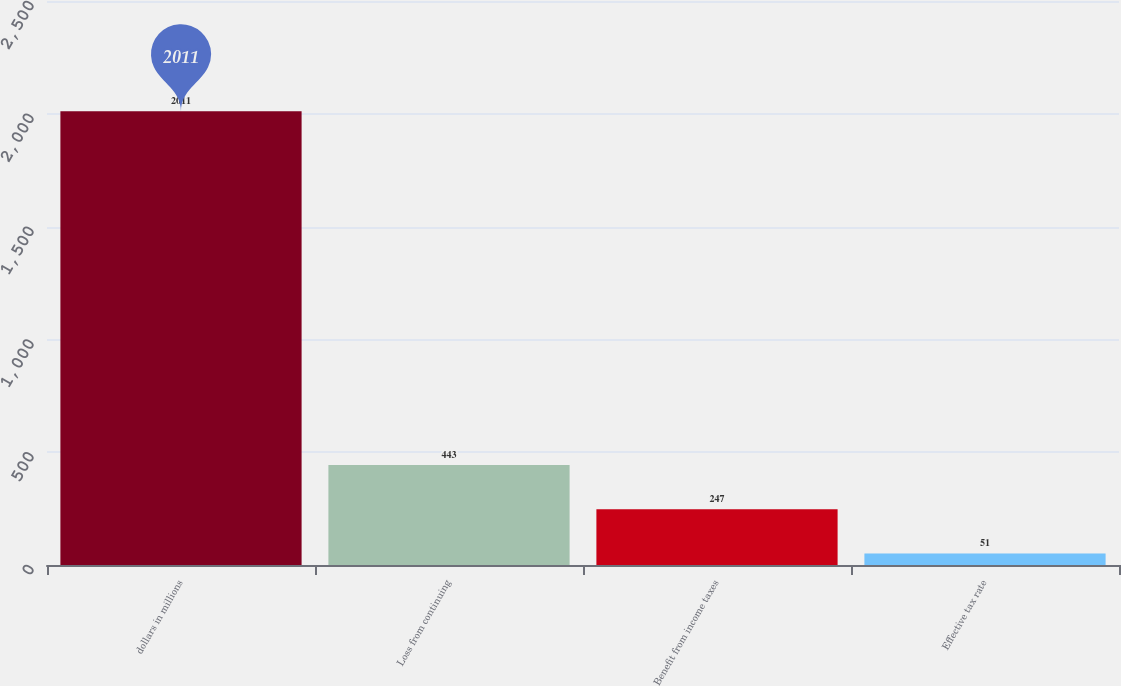<chart> <loc_0><loc_0><loc_500><loc_500><bar_chart><fcel>dollars in millions<fcel>Loss from continuing<fcel>Benefit from income taxes<fcel>Effective tax rate<nl><fcel>2011<fcel>443<fcel>247<fcel>51<nl></chart> 